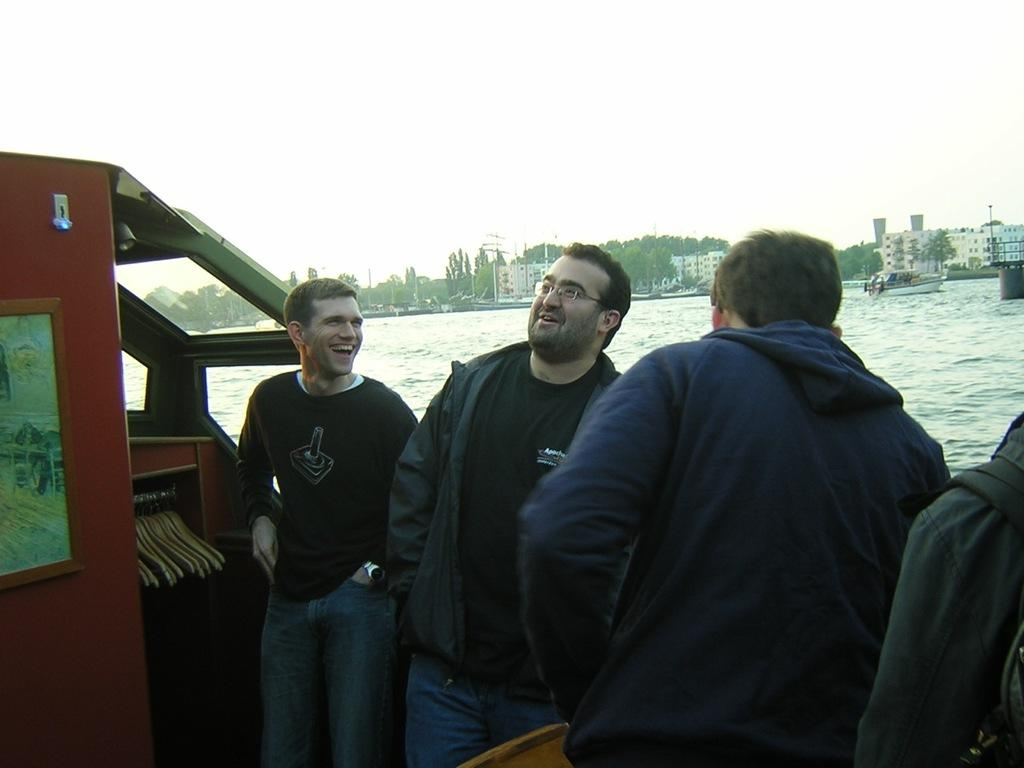What are the men in the image wearing? The men in the image are wearing jackets. Where are the men located in the image? The men are standing in a boat. What body of water is the boat on? The boat is on the sea. What can be seen in the background of the image? There are buildings and trees in the background of the image. What is visible above the buildings? The sky is visible above the buildings. Can you see a wren perched on the boat in the image? There is no wren present in the image. How does the coal affect the boat's movement in the image? There is no coal mentioned in the image, so its effect on the boat's movement cannot be determined. 